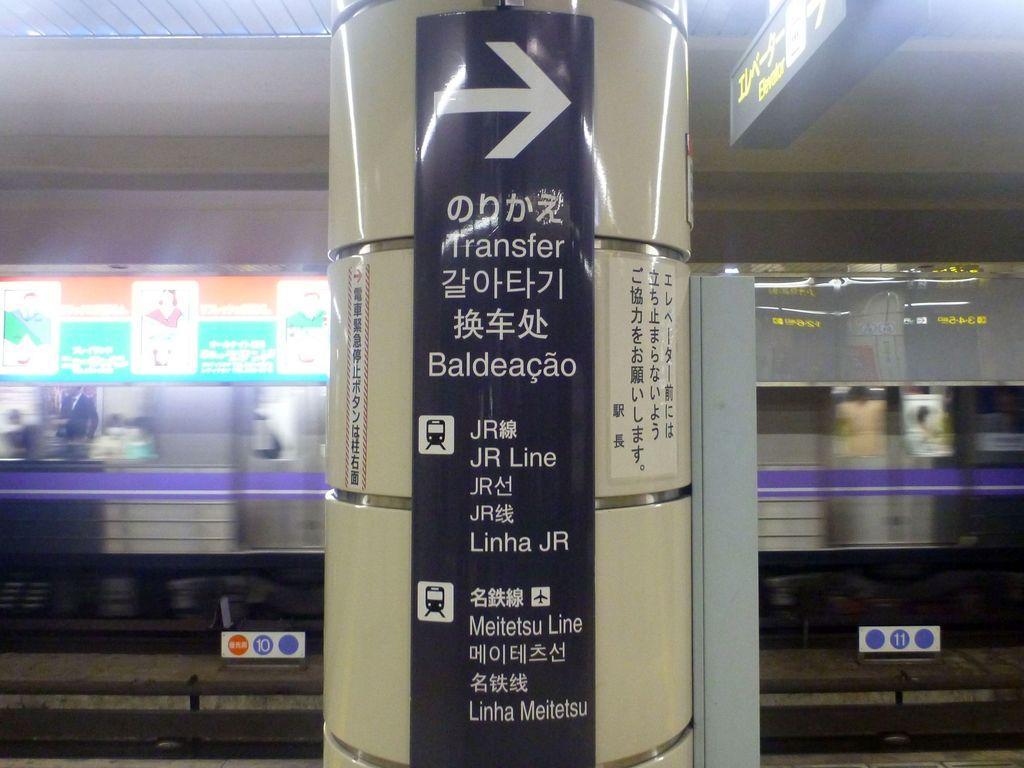<image>
Present a compact description of the photo's key features. A black sign pointing right with several languages under it 